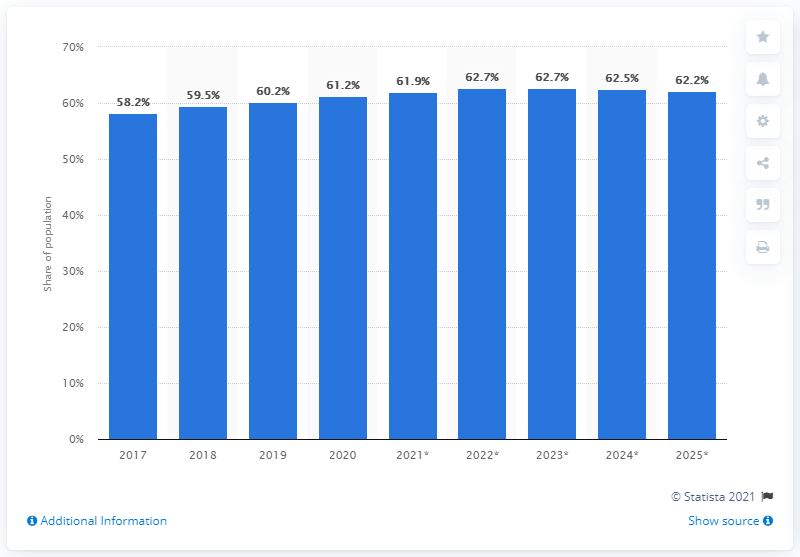Highlight a few significant elements in this photo. The projected penetration of Facebook users in the Netherlands in 2025 is expected to be 62.2%. 